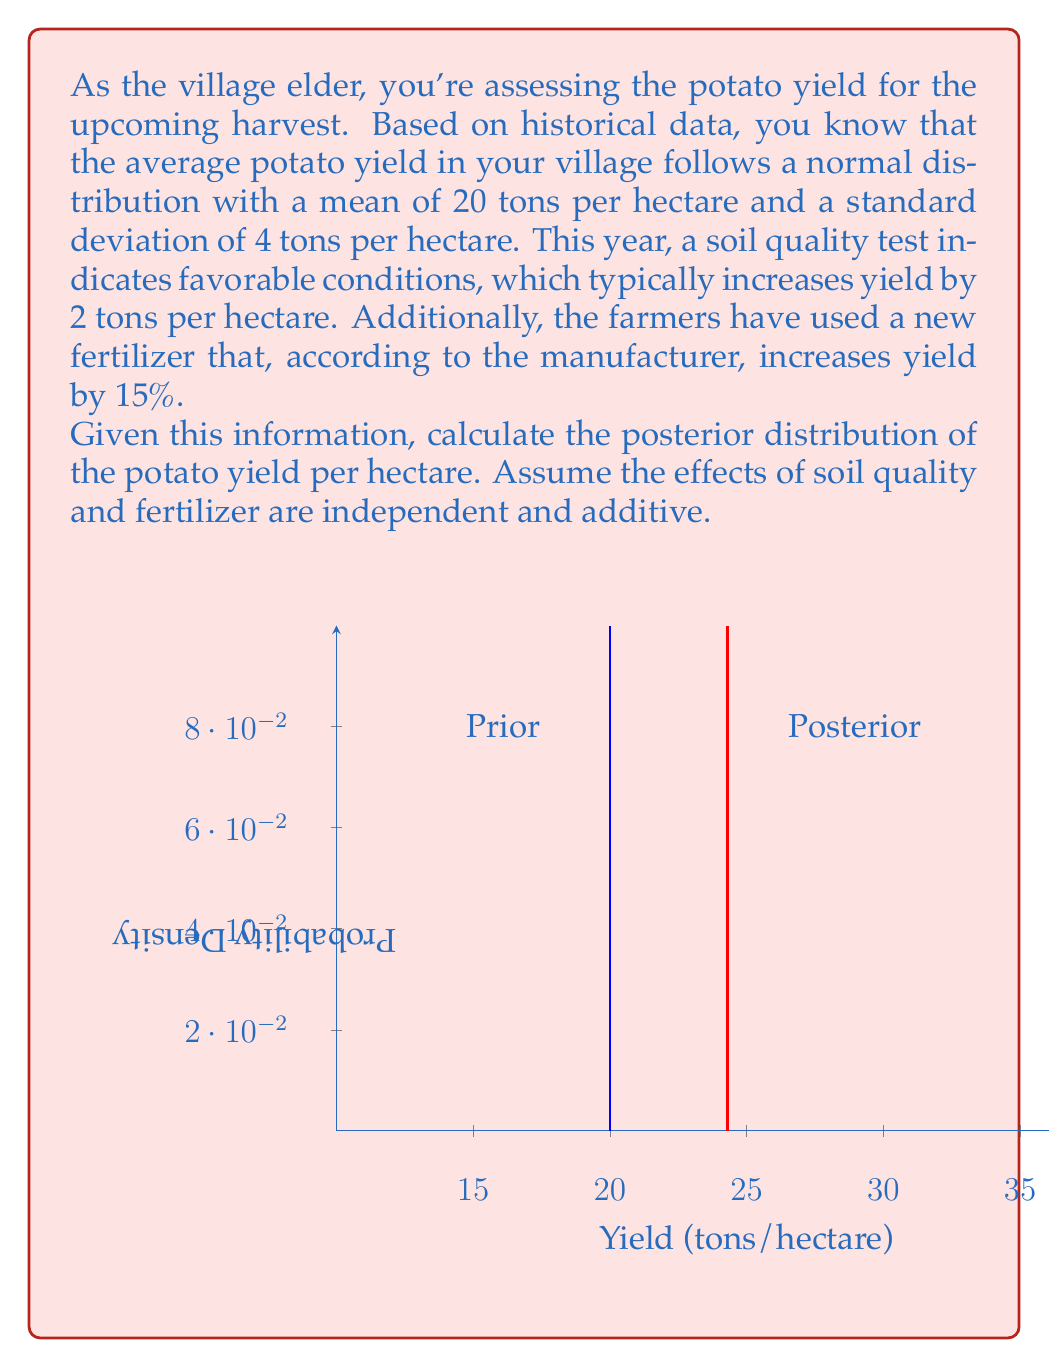What is the answer to this math problem? Let's approach this step-by-step using Bayesian inference:

1) Prior distribution:
   The prior distribution of potato yield is normal with mean $\mu_0 = 20$ and standard deviation $\sigma_0 = 4$.
   $$Y \sim N(20, 4^2)$$

2) Likelihood:
   We have two pieces of new information:
   a) Soil quality increases yield by 2 tons/hectare
   b) Fertilizer increases yield by 15%

   Let's combine these effects:
   - Soil quality effect: +2 tons/hectare
   - Fertilizer effect: 15% of 20 = 0.15 * 20 = 3 tons/hectare
   
   Total effect: 2 + 3 = 5 tons/hectare

   We can treat this as our "observation" with some uncertainty. Let's assume the uncertainty in this combined effect is $\sigma = 2$ tons/hectare.

   So our likelihood is:
   $$L(Y) \sim N(25, 2^2)$$

3) Posterior distribution:
   To calculate the posterior, we use the formula for updating a normal prior with normal likelihood:

   $$\mu_{posterior} = \frac{\sigma_L^2\mu_0 + \sigma_0^2\mu_L}{\sigma_L^2 + \sigma_0^2}$$
   $$\sigma_{posterior}^2 = \frac{\sigma_L^2\sigma_0^2}{\sigma_L^2 + \sigma_0^2}$$

   Where:
   $\mu_0 = 20$, $\sigma_0 = 4$, $\mu_L = 25$, $\sigma_L = 2$

   Calculating:
   $$\mu_{posterior} = \frac{2^2 * 20 + 4^2 * 25}{2^2 + 4^2} = \frac{80 + 400}{20} = 24.3$$

   $$\sigma_{posterior}^2 = \frac{2^2 * 4^2}{2^2 + 4^2} = \frac{64}{20} = 3.2$$
   $$\sigma_{posterior} = \sqrt{3.2} \approx 1.79$$

Therefore, the posterior distribution is:
$$Y_{posterior} \sim N(24.3, 1.79^2)$$
Answer: $N(24.3, 1.79^2)$ 